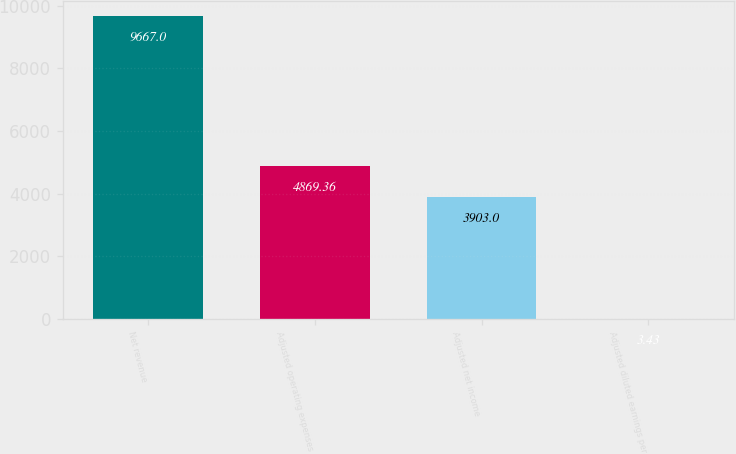<chart> <loc_0><loc_0><loc_500><loc_500><bar_chart><fcel>Net revenue<fcel>Adjusted operating expenses<fcel>Adjusted net income<fcel>Adjusted diluted earnings per<nl><fcel>9667<fcel>4869.36<fcel>3903<fcel>3.43<nl></chart> 